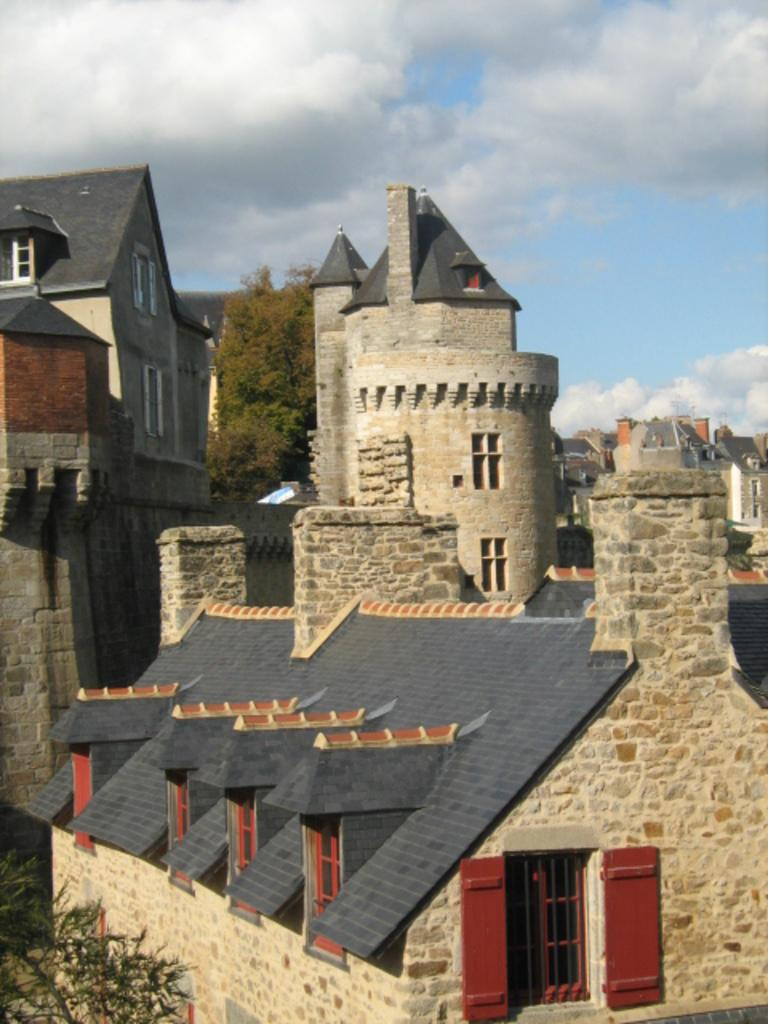What type of structures can be seen in the image? There are buildings in the image. What other natural elements are present in the image? There are plants and trees in the image. Are there any architectural features visible on the buildings? Yes, there are chimneys in the image. What can be seen in the background of the image? The sky is visible in the image, and clouds are present in the sky. How many toes does the tree have in the image? Trees do not have toes; they have branches and leaves. 